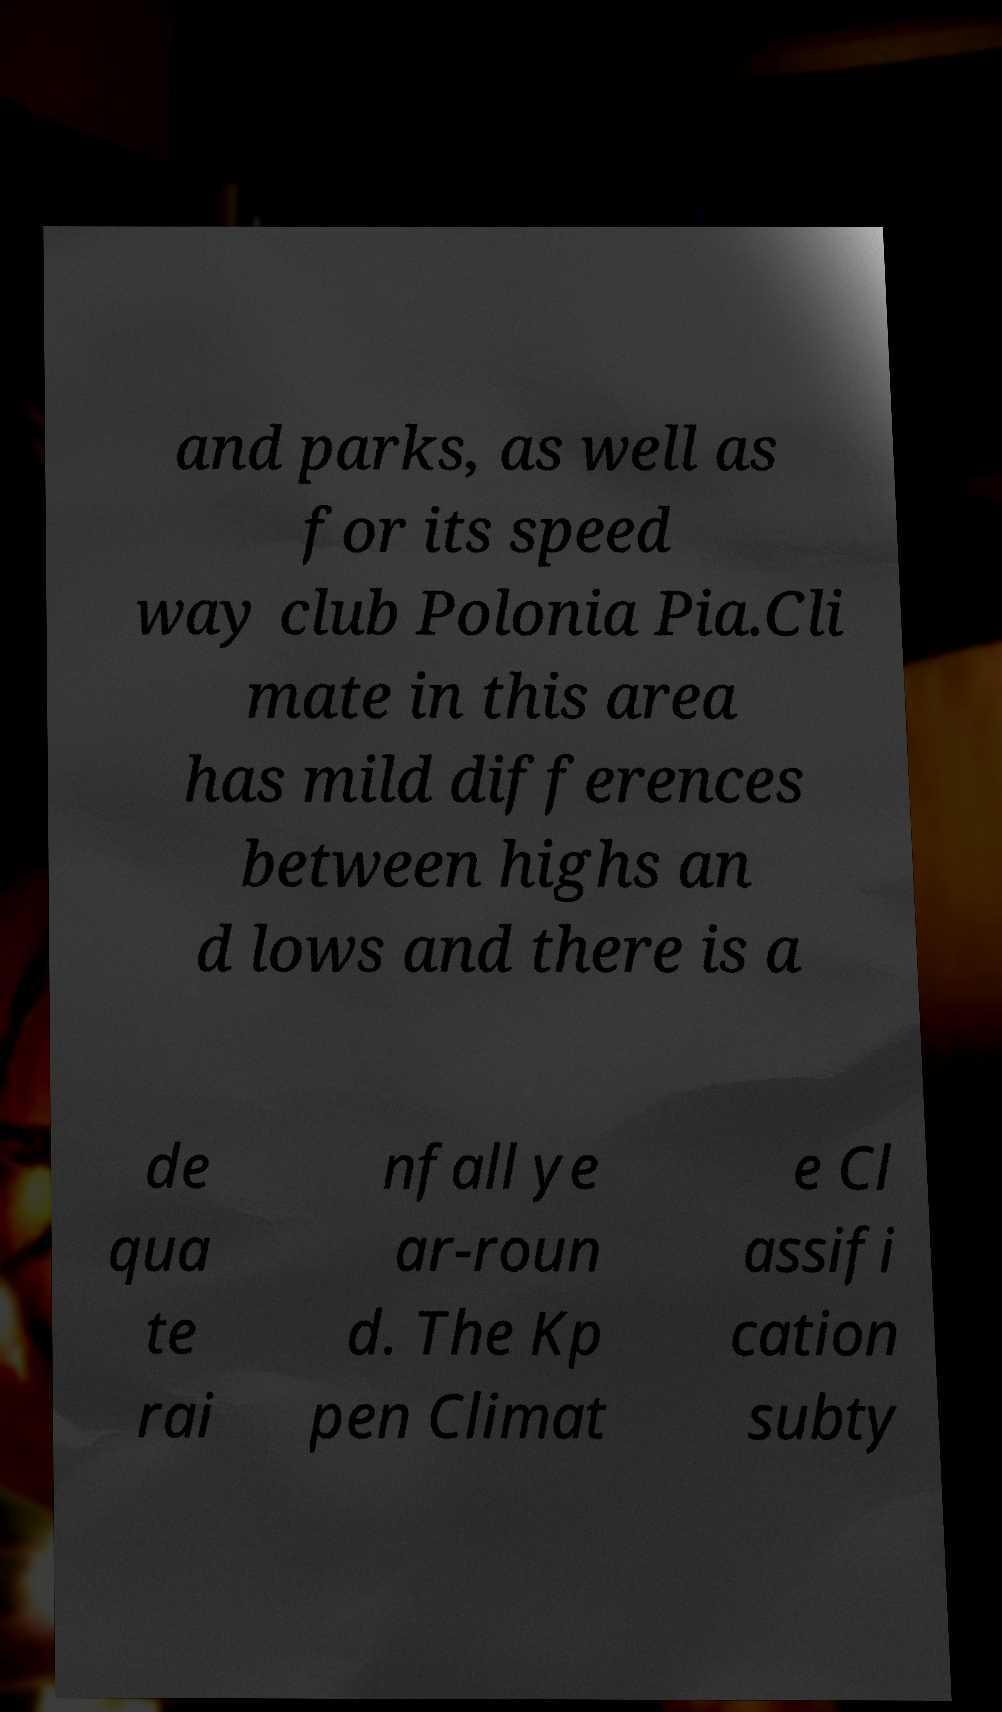Please identify and transcribe the text found in this image. and parks, as well as for its speed way club Polonia Pia.Cli mate in this area has mild differences between highs an d lows and there is a de qua te rai nfall ye ar-roun d. The Kp pen Climat e Cl assifi cation subty 